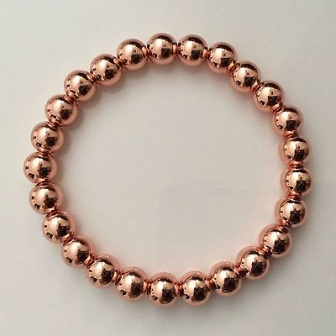Why do you think the bracelet is arranged in such a simple manner on a white background? The bracelet is arranged simply on a white background to highlight its design without any distractions. This minimalist presentation is often used in product photography to ensure the focus remains on the item itself, emphasizing its craftsmanship, texture, and color. The stark contrast between the copper-colored beads and the white surface enhances the visual appeal, making the bracelet the focal point of the image. Can you imagine a scenario where this bracelet is part of a significant story or moment in someone's life? One could imagine this bracelet being a cherished heirloom, passed down through generations in a family. Each bead could symbolize a significant event or milestone in the family's history. Perhaps, it was first crafted by an ancestor as a token of love, given to a bride on her wedding day. Over the years, it has been handed down during pivotal moments—graduations, weddings, and anniversaries—each bead absorbing the essence of those experiences. To the current wearer, it is more than just an accessory; it is a tangible link to the lineage, carrying with it the weight of legacy, love, and continuity. 